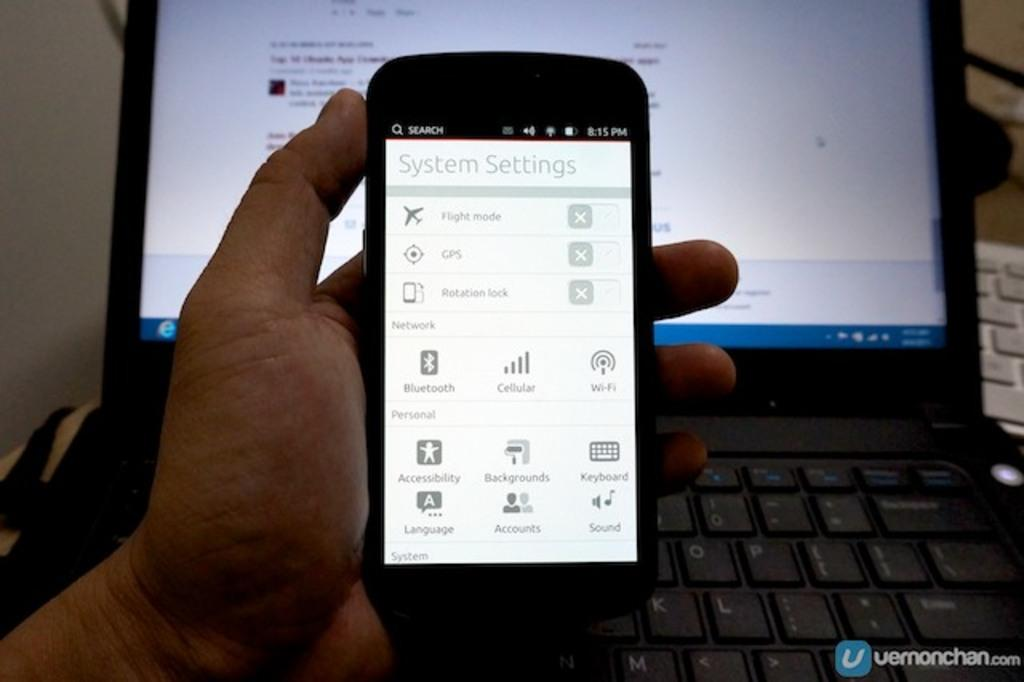<image>
Share a concise interpretation of the image provided. The systems setting screen of a smart phone 